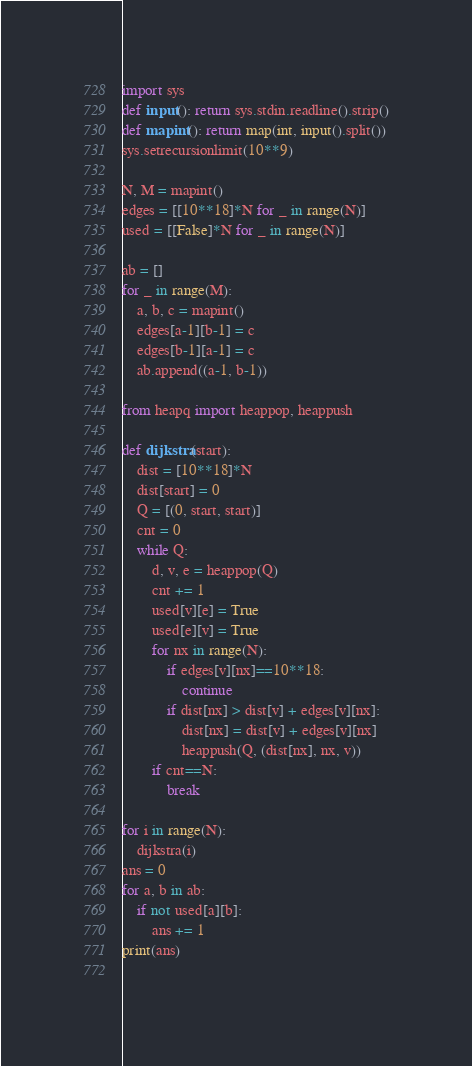<code> <loc_0><loc_0><loc_500><loc_500><_Python_>import sys
def input(): return sys.stdin.readline().strip()
def mapint(): return map(int, input().split())
sys.setrecursionlimit(10**9)

N, M = mapint()
edges = [[10**18]*N for _ in range(N)]
used = [[False]*N for _ in range(N)]

ab = []
for _ in range(M):
    a, b, c = mapint()
    edges[a-1][b-1] = c
    edges[b-1][a-1] = c
    ab.append((a-1, b-1))

from heapq import heappop, heappush

def dijkstra(start):
    dist = [10**18]*N
    dist[start] = 0
    Q = [(0, start, start)]
    cnt = 0
    while Q:
        d, v, e = heappop(Q)
        cnt += 1
        used[v][e] = True
        used[e][v] = True
        for nx in range(N):
            if edges[v][nx]==10**18:
                continue
            if dist[nx] > dist[v] + edges[v][nx]:
                dist[nx] = dist[v] + edges[v][nx]
                heappush(Q, (dist[nx], nx, v))
        if cnt==N:
            break

for i in range(N):
    dijkstra(i)
ans = 0
for a, b in ab:
    if not used[a][b]:
        ans += 1
print(ans)
        </code> 